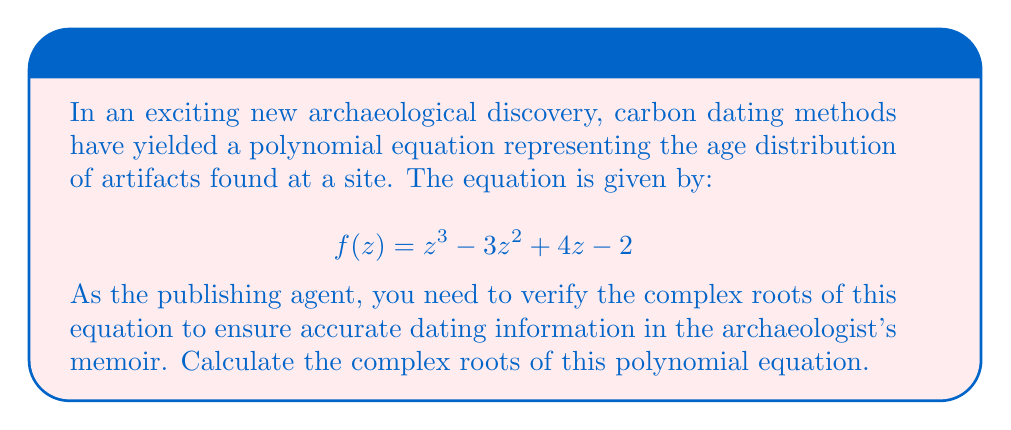Show me your answer to this math problem. To find the complex roots of the polynomial equation $f(z) = z^3 - 3z^2 + 4z - 2$, we can use the following steps:

1) First, let's check if there are any real roots by using the rational root theorem. The possible rational roots are the factors of the constant term: ±1, ±2. Testing these:

   $f(1) = 1 - 3 + 4 - 2 = 0$

   We find that $z = 1$ is a root.

2) Now we can factor out $(z-1)$:

   $f(z) = (z-1)(z^2 - 2z + 2)$

3) For the quadratic factor $z^2 - 2z + 2$, we can use the quadratic formula:

   $z = \frac{-b \pm \sqrt{b^2 - 4ac}}{2a}$

   Where $a=1$, $b=-2$, and $c=2$

4) Substituting:

   $z = \frac{2 \pm \sqrt{4 - 8}}{2} = \frac{2 \pm \sqrt{-4}}{2} = \frac{2 \pm 2i}{2} = 1 \pm i$

5) Therefore, the other two roots are $1+i$ and $1-i$.
Answer: $z_1 = 1$, $z_2 = 1+i$, $z_3 = 1-i$ 